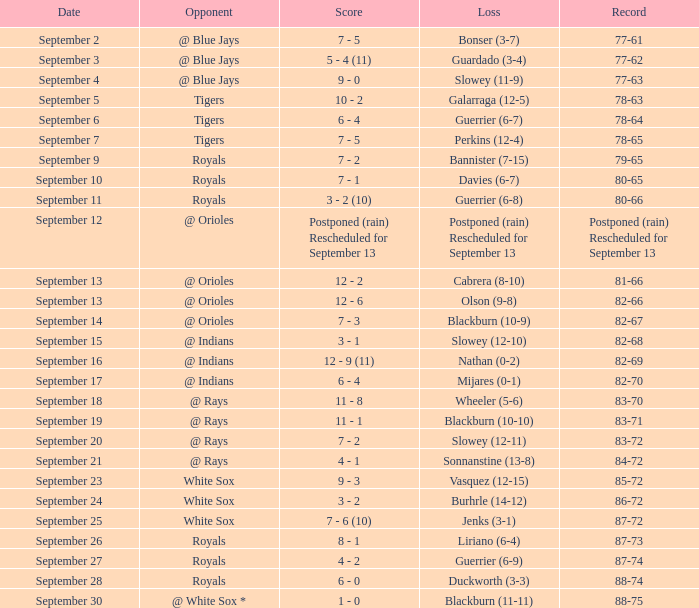What opponent has the record of 78-63? Tigers. 